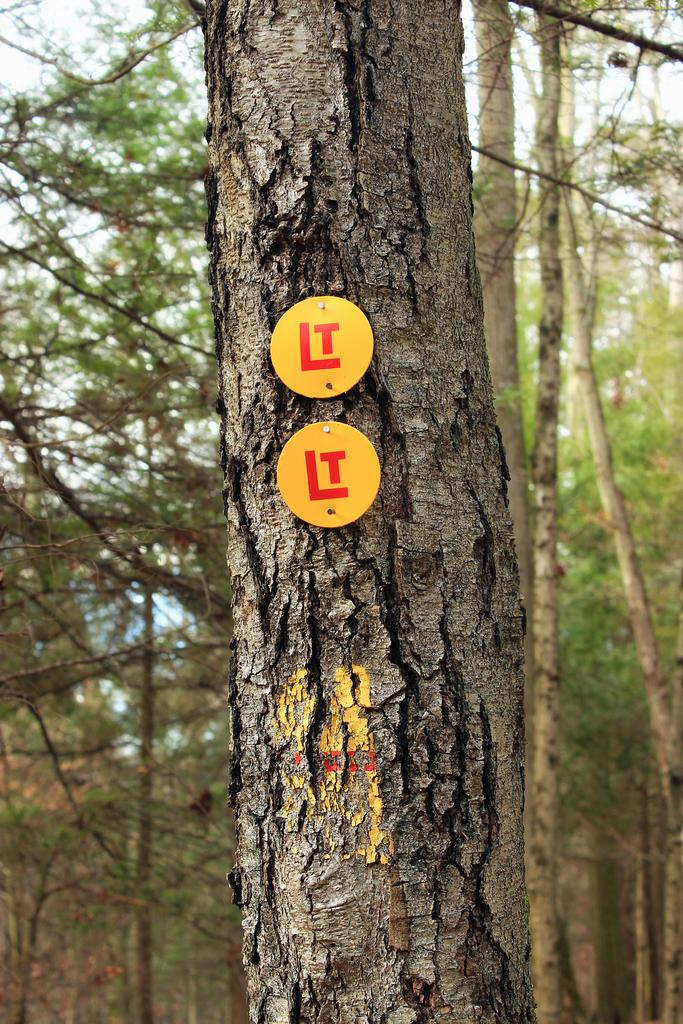What type of vegetation can be seen in the image? There are trees in the image. Are there any objects attached to the trees? Yes, there are yellow colored objects with text on the branch of one of the trees. What can be seen in the background of the image? The sky is visible in the image. How many apples are hanging from the tongue in the image? There are no apples or tongues present in the image. 